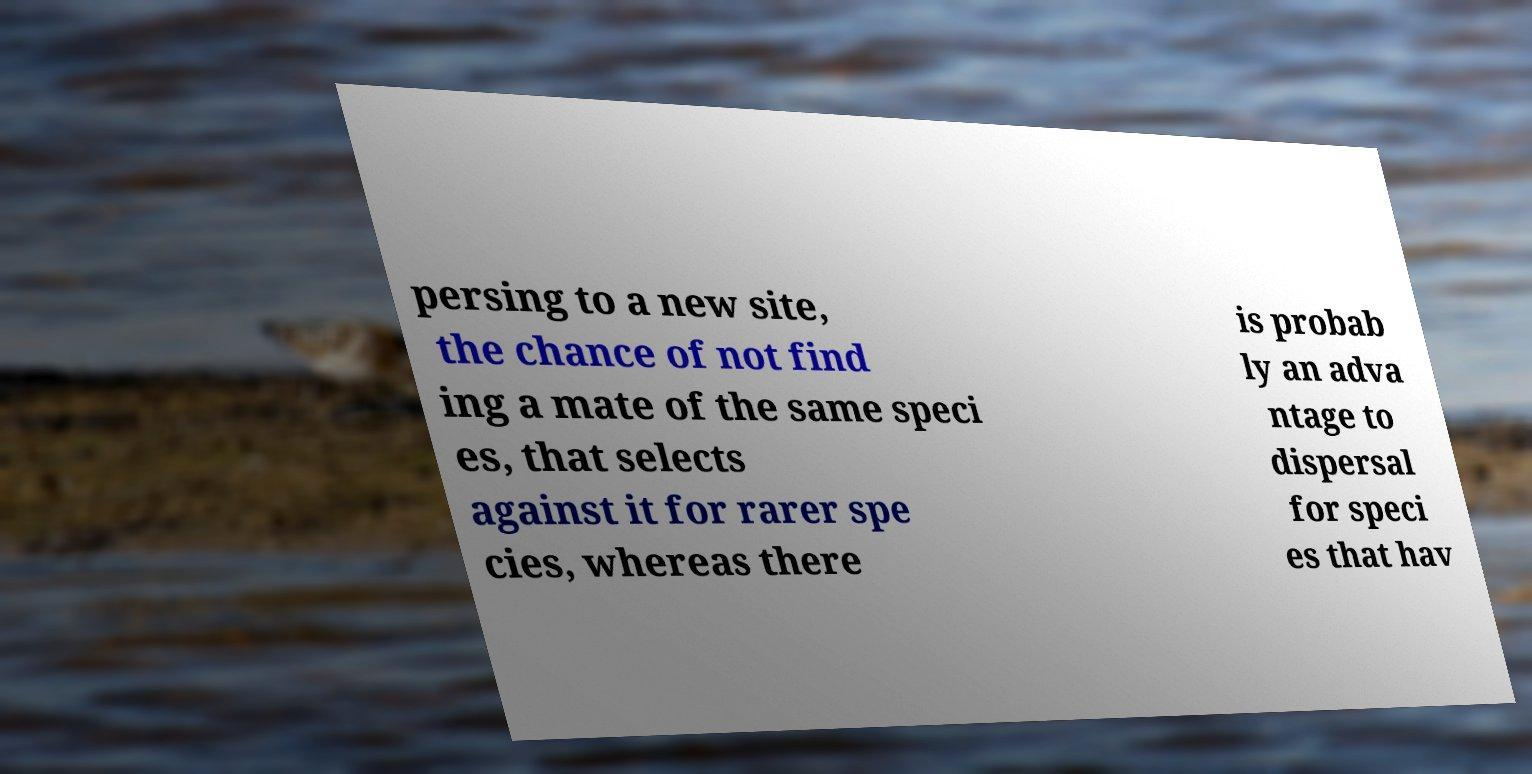Can you read and provide the text displayed in the image?This photo seems to have some interesting text. Can you extract and type it out for me? persing to a new site, the chance of not find ing a mate of the same speci es, that selects against it for rarer spe cies, whereas there is probab ly an adva ntage to dispersal for speci es that hav 